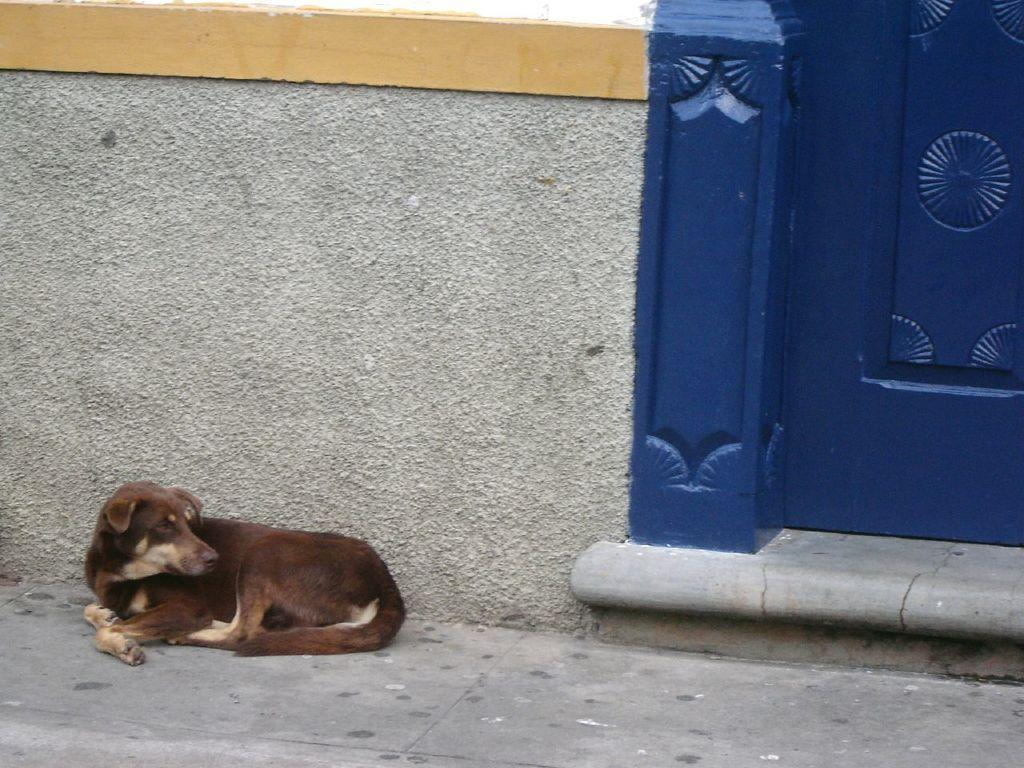What animal can be seen in the image? There is a dog in the image. Where is the dog located in relation to other objects in the image? The dog is sitting near a wall. What color is the door visible in the image? There is a blue door in the image. Can you see any wrens flying near the dog in the image? There are no wrens visible in the image. Is there a trail leading up to the blue door in the image? There is no trail visible in the image. 